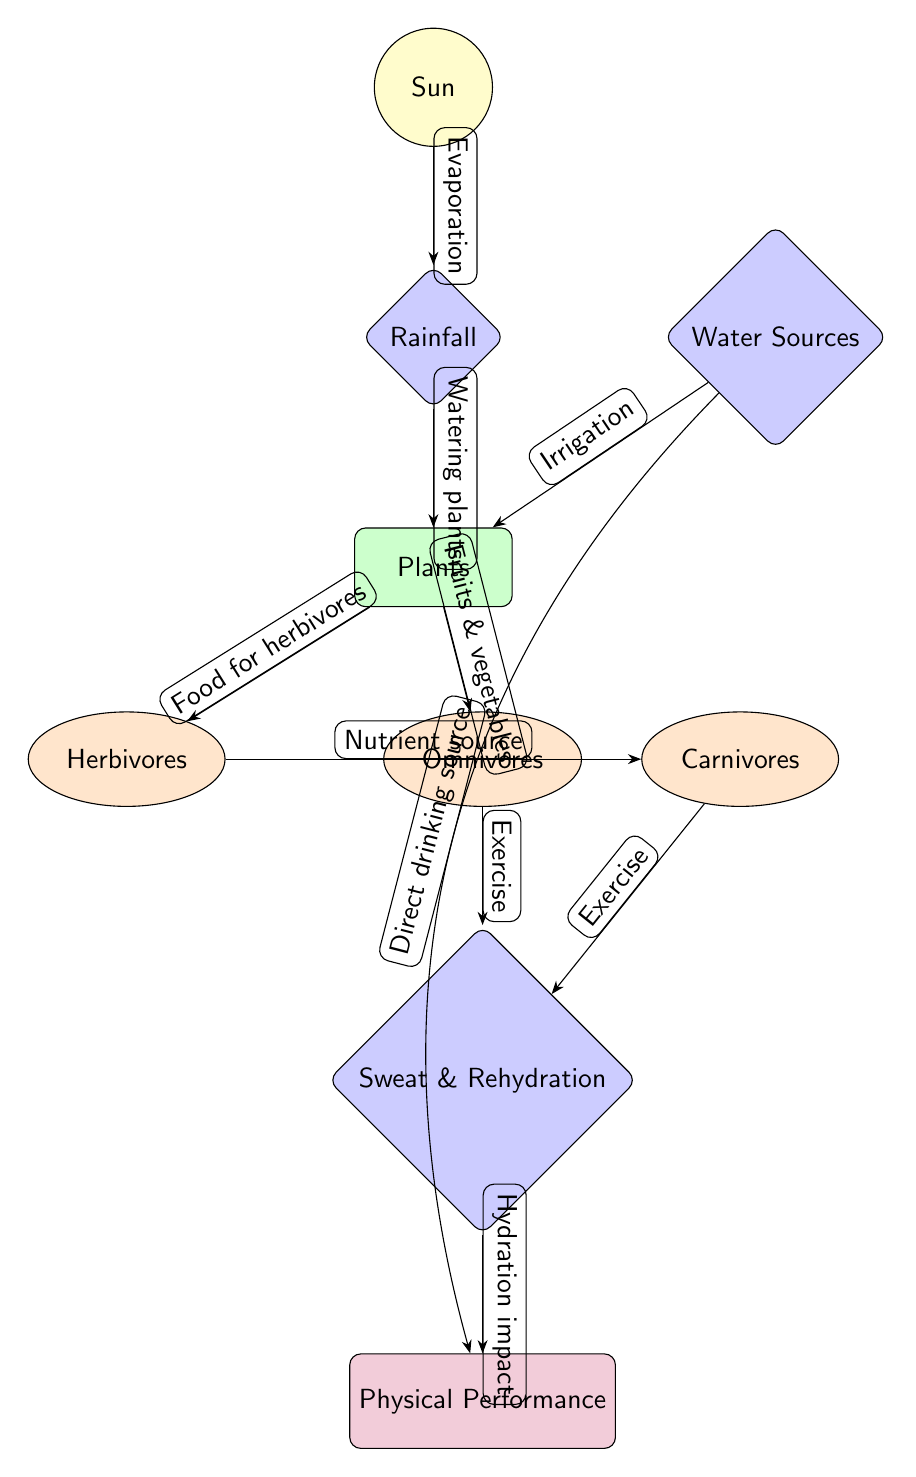What is the last node in the diagram? The last node in the diagram represents the outcome of physical performance and is labeled as "Physical Performance." Since it's the final point where hydration impacts athletic performance, it concludes the food chain.
Answer: Physical Performance How many types of animals are there in the diagram? The diagram features three types of animals: "Herbivores," "Carnivores," and "Omnivores." Each animal type plays a distinct role in the food chain, relating to plants and each other.
Answer: Three What role does "Water Sources" play in relation to plants? "Water Sources" is connected to "Plants" through the relationship of "Irrigation." This indicates that water from various sources is used to support the growth of plants in the food chain.
Answer: Irrigation What impact does sweat have on athletic performance? In the diagram, "Sweat" links to "Physical Performance" through the relationship labeled as "Hydration impact," indicating that proper hydration through sweat affects athletic performance positively.
Answer: Hydration impact Which node is directly connected to both "Carnivores" and "Herbivores"? The node that connects both "Carnivores" and "Herbivores" is "Plants." It serves as the primary food source for herbivores and indirectly supports carnivores through their prey.
Answer: Plants What is the relationship between "Plants" and "Omnivores"? The relationship is described as "Fruits & vegetables," meaning that omnivores get part of their nutrition directly from plants by consuming fruits and vegetables.
Answer: Fruits & vegetables How does "Rainfall" contribute to the food chain? "Rainfall" contributes through the relationship labeled "Watering plants," which shows how rainfall provides moisture necessary for plants to thrive, establishing the foundation of the food chain.
Answer: Watering plants What element precedes "Sweat & Rehydration"? The element that precedes "Sweat & Rehydration" is either "Carnivores" or "Omnivores" since both exercise and produce sweat, impacting hydration. The diagram illustrates that both classes of animals lead to this aspect of performance.
Answer: Carnivores and Omnivores Which node represents the primary source of water in the diagram? The primary source of water is represented by "Water Sources," which serves as a key node providing water necessary for various entities in the food chain.
Answer: Water Sources 